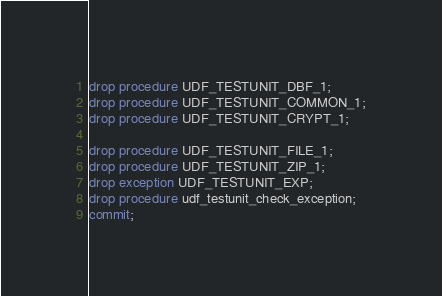Convert code to text. <code><loc_0><loc_0><loc_500><loc_500><_SQL_>drop procedure UDF_TESTUNIT_DBF_1;
drop procedure UDF_TESTUNIT_COMMON_1;
drop procedure UDF_TESTUNIT_CRYPT_1;

drop procedure UDF_TESTUNIT_FILE_1;
drop procedure UDF_TESTUNIT_ZIP_1;
drop exception UDF_TESTUNIT_EXP;
drop procedure udf_testunit_check_exception;
commit;</code> 